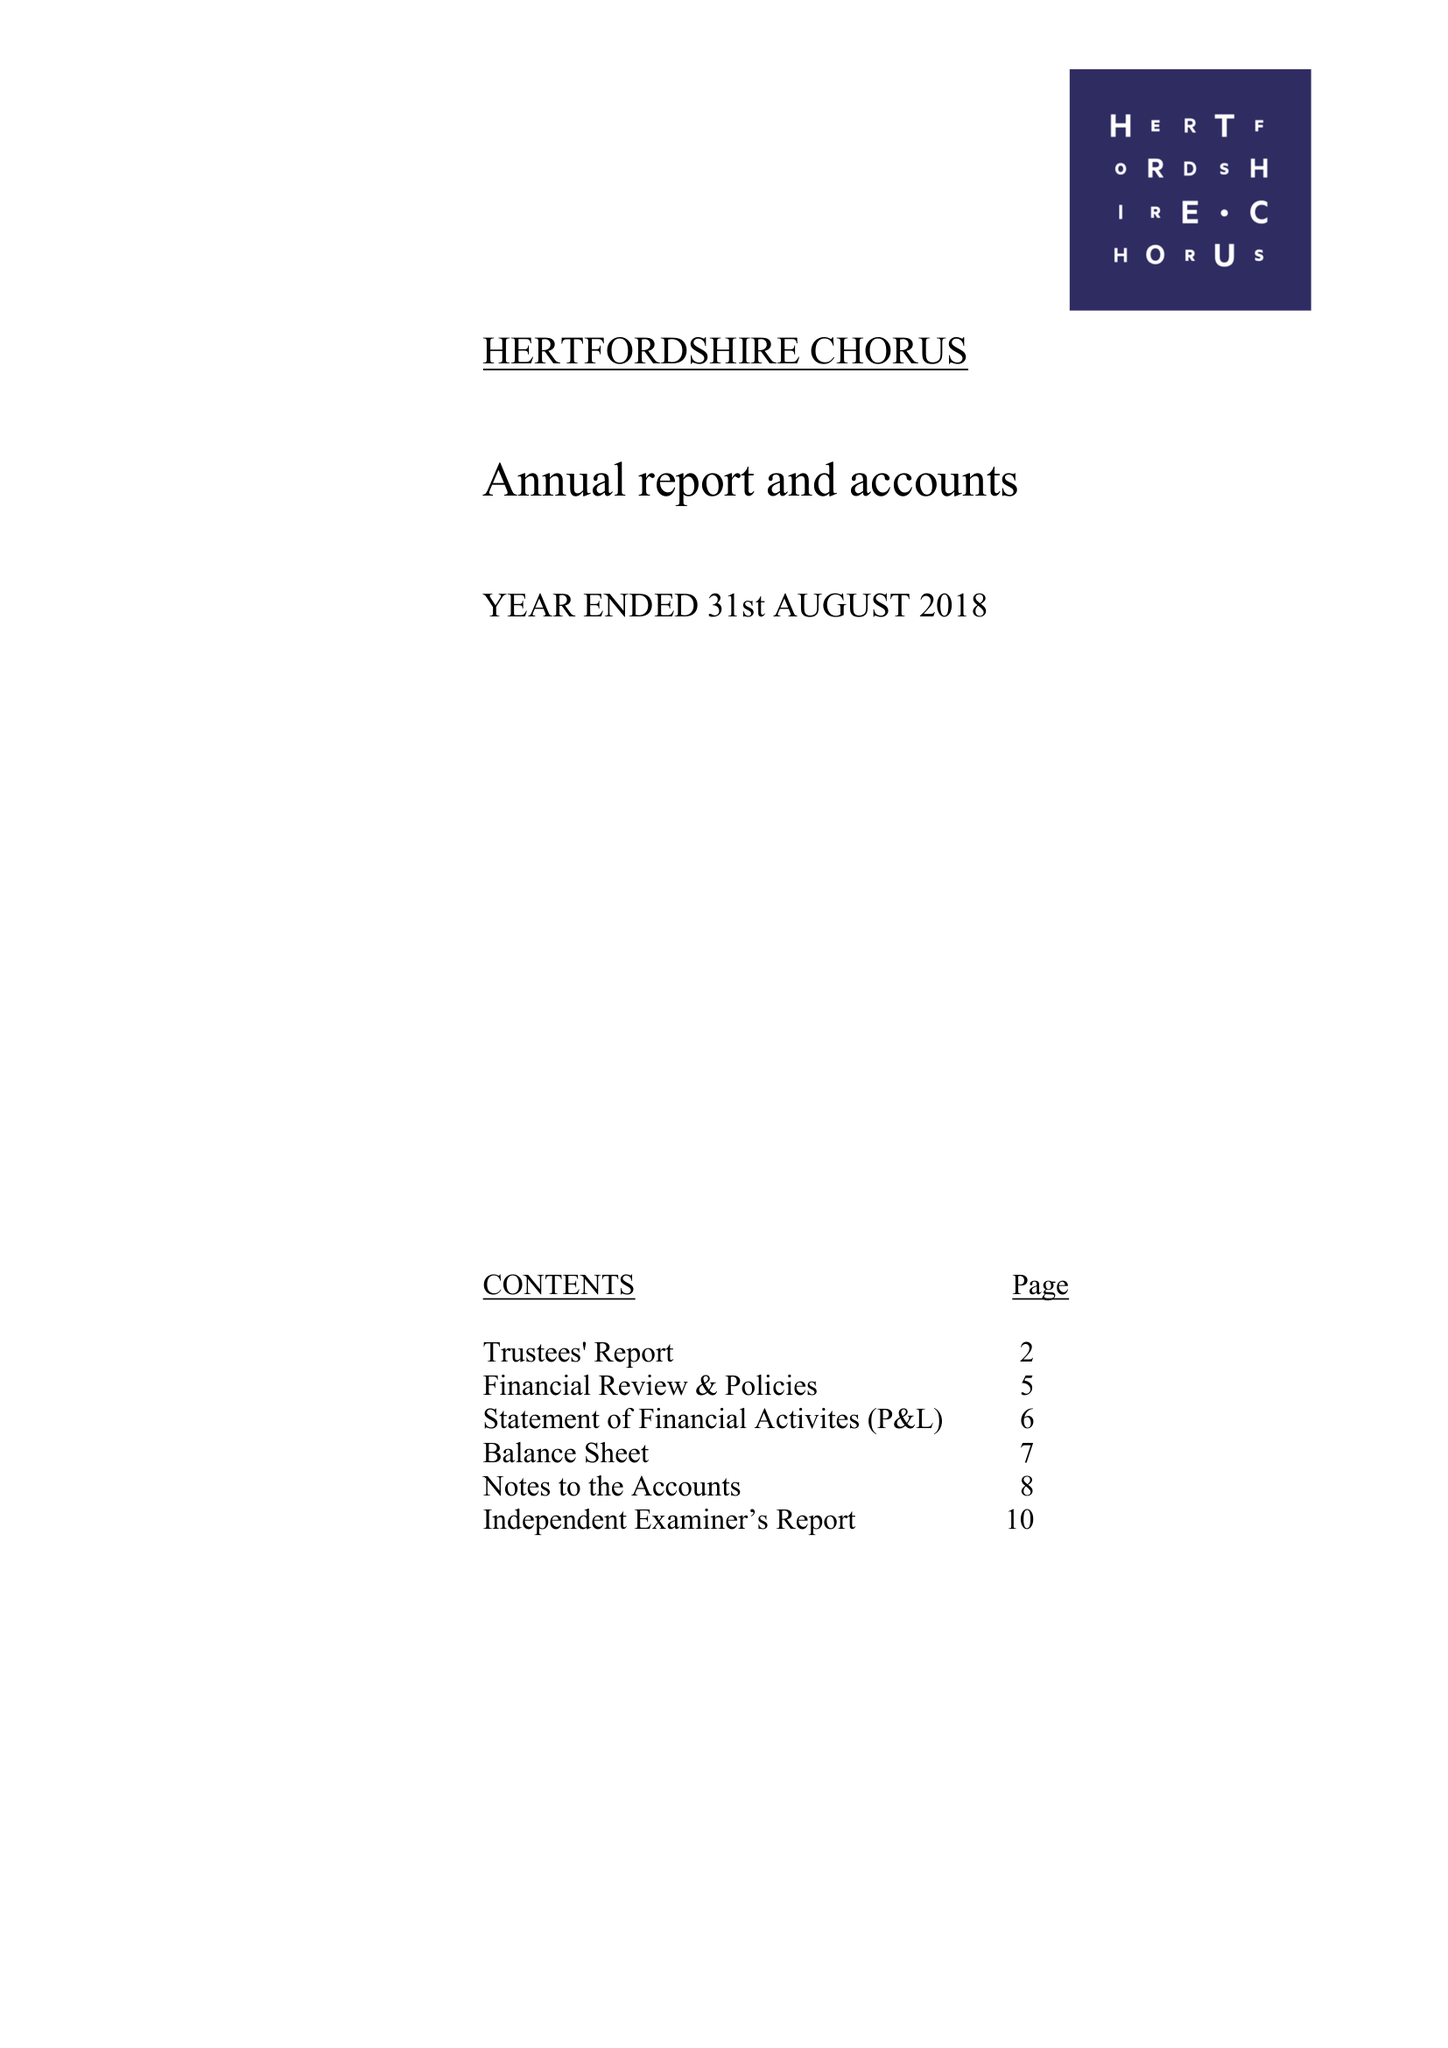What is the value for the charity_name?
Answer the question using a single word or phrase. Hertfordshire Chorus 